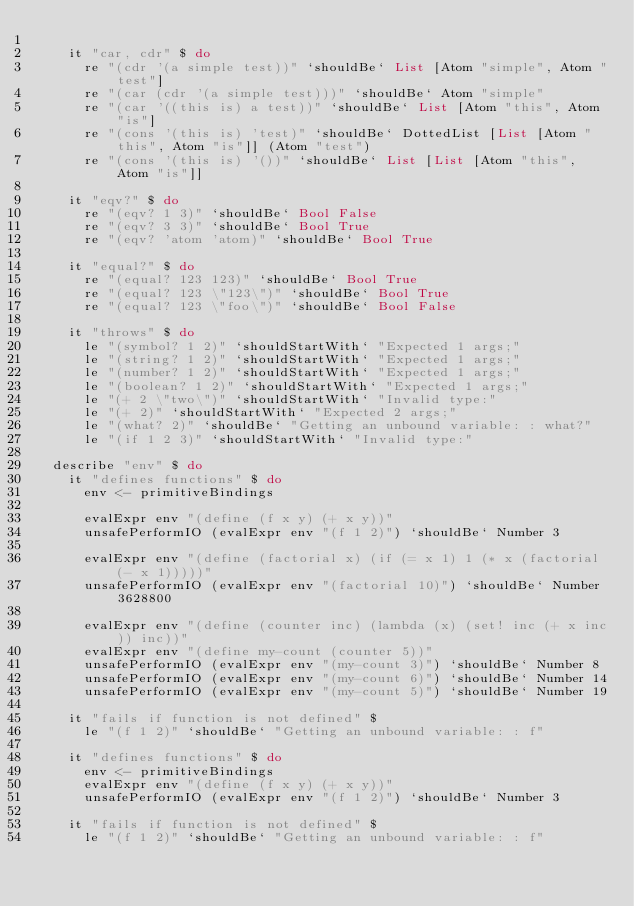Convert code to text. <code><loc_0><loc_0><loc_500><loc_500><_Haskell_>
    it "car, cdr" $ do
      re "(cdr '(a simple test))" `shouldBe` List [Atom "simple", Atom "test"]
      re "(car (cdr '(a simple test)))" `shouldBe` Atom "simple"
      re "(car '((this is) a test))" `shouldBe` List [Atom "this", Atom "is"]
      re "(cons '(this is) 'test)" `shouldBe` DottedList [List [Atom "this", Atom "is"]] (Atom "test")
      re "(cons '(this is) '())" `shouldBe` List [List [Atom "this", Atom "is"]]

    it "eqv?" $ do
      re "(eqv? 1 3)" `shouldBe` Bool False
      re "(eqv? 3 3)" `shouldBe` Bool True
      re "(eqv? 'atom 'atom)" `shouldBe` Bool True

    it "equal?" $ do
      re "(equal? 123 123)" `shouldBe` Bool True
      re "(equal? 123 \"123\")" `shouldBe` Bool True
      re "(equal? 123 \"foo\")" `shouldBe` Bool False

    it "throws" $ do
      le "(symbol? 1 2)" `shouldStartWith` "Expected 1 args;"
      le "(string? 1 2)" `shouldStartWith` "Expected 1 args;"
      le "(number? 1 2)" `shouldStartWith` "Expected 1 args;"
      le "(boolean? 1 2)" `shouldStartWith` "Expected 1 args;"
      le "(+ 2 \"two\")" `shouldStartWith` "Invalid type:"
      le "(+ 2)" `shouldStartWith` "Expected 2 args;"
      le "(what? 2)" `shouldBe` "Getting an unbound variable: : what?"
      le "(if 1 2 3)" `shouldStartWith` "Invalid type:"

  describe "env" $ do
    it "defines functions" $ do
      env <- primitiveBindings

      evalExpr env "(define (f x y) (+ x y))"
      unsafePerformIO (evalExpr env "(f 1 2)") `shouldBe` Number 3

      evalExpr env "(define (factorial x) (if (= x 1) 1 (* x (factorial (- x 1)))))"
      unsafePerformIO (evalExpr env "(factorial 10)") `shouldBe` Number 3628800

      evalExpr env "(define (counter inc) (lambda (x) (set! inc (+ x inc)) inc))"
      evalExpr env "(define my-count (counter 5))"
      unsafePerformIO (evalExpr env "(my-count 3)") `shouldBe` Number 8
      unsafePerformIO (evalExpr env "(my-count 6)") `shouldBe` Number 14
      unsafePerformIO (evalExpr env "(my-count 5)") `shouldBe` Number 19

    it "fails if function is not defined" $
      le "(f 1 2)" `shouldBe` "Getting an unbound variable: : f"

    it "defines functions" $ do
      env <- primitiveBindings
      evalExpr env "(define (f x y) (+ x y))"
      unsafePerformIO (evalExpr env "(f 1 2)") `shouldBe` Number 3

    it "fails if function is not defined" $
      le "(f 1 2)" `shouldBe` "Getting an unbound variable: : f"
</code> 